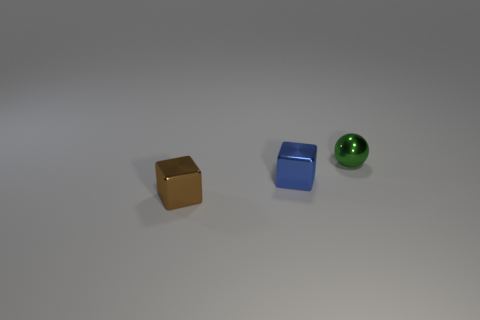Subtract all red spheres. Subtract all yellow cylinders. How many spheres are left? 1 Add 1 tiny green objects. How many objects exist? 4 Subtract all cubes. How many objects are left? 1 Subtract all brown shiny objects. Subtract all green balls. How many objects are left? 1 Add 2 small green spheres. How many small green spheres are left? 3 Add 3 small blue objects. How many small blue objects exist? 4 Subtract 1 blue cubes. How many objects are left? 2 